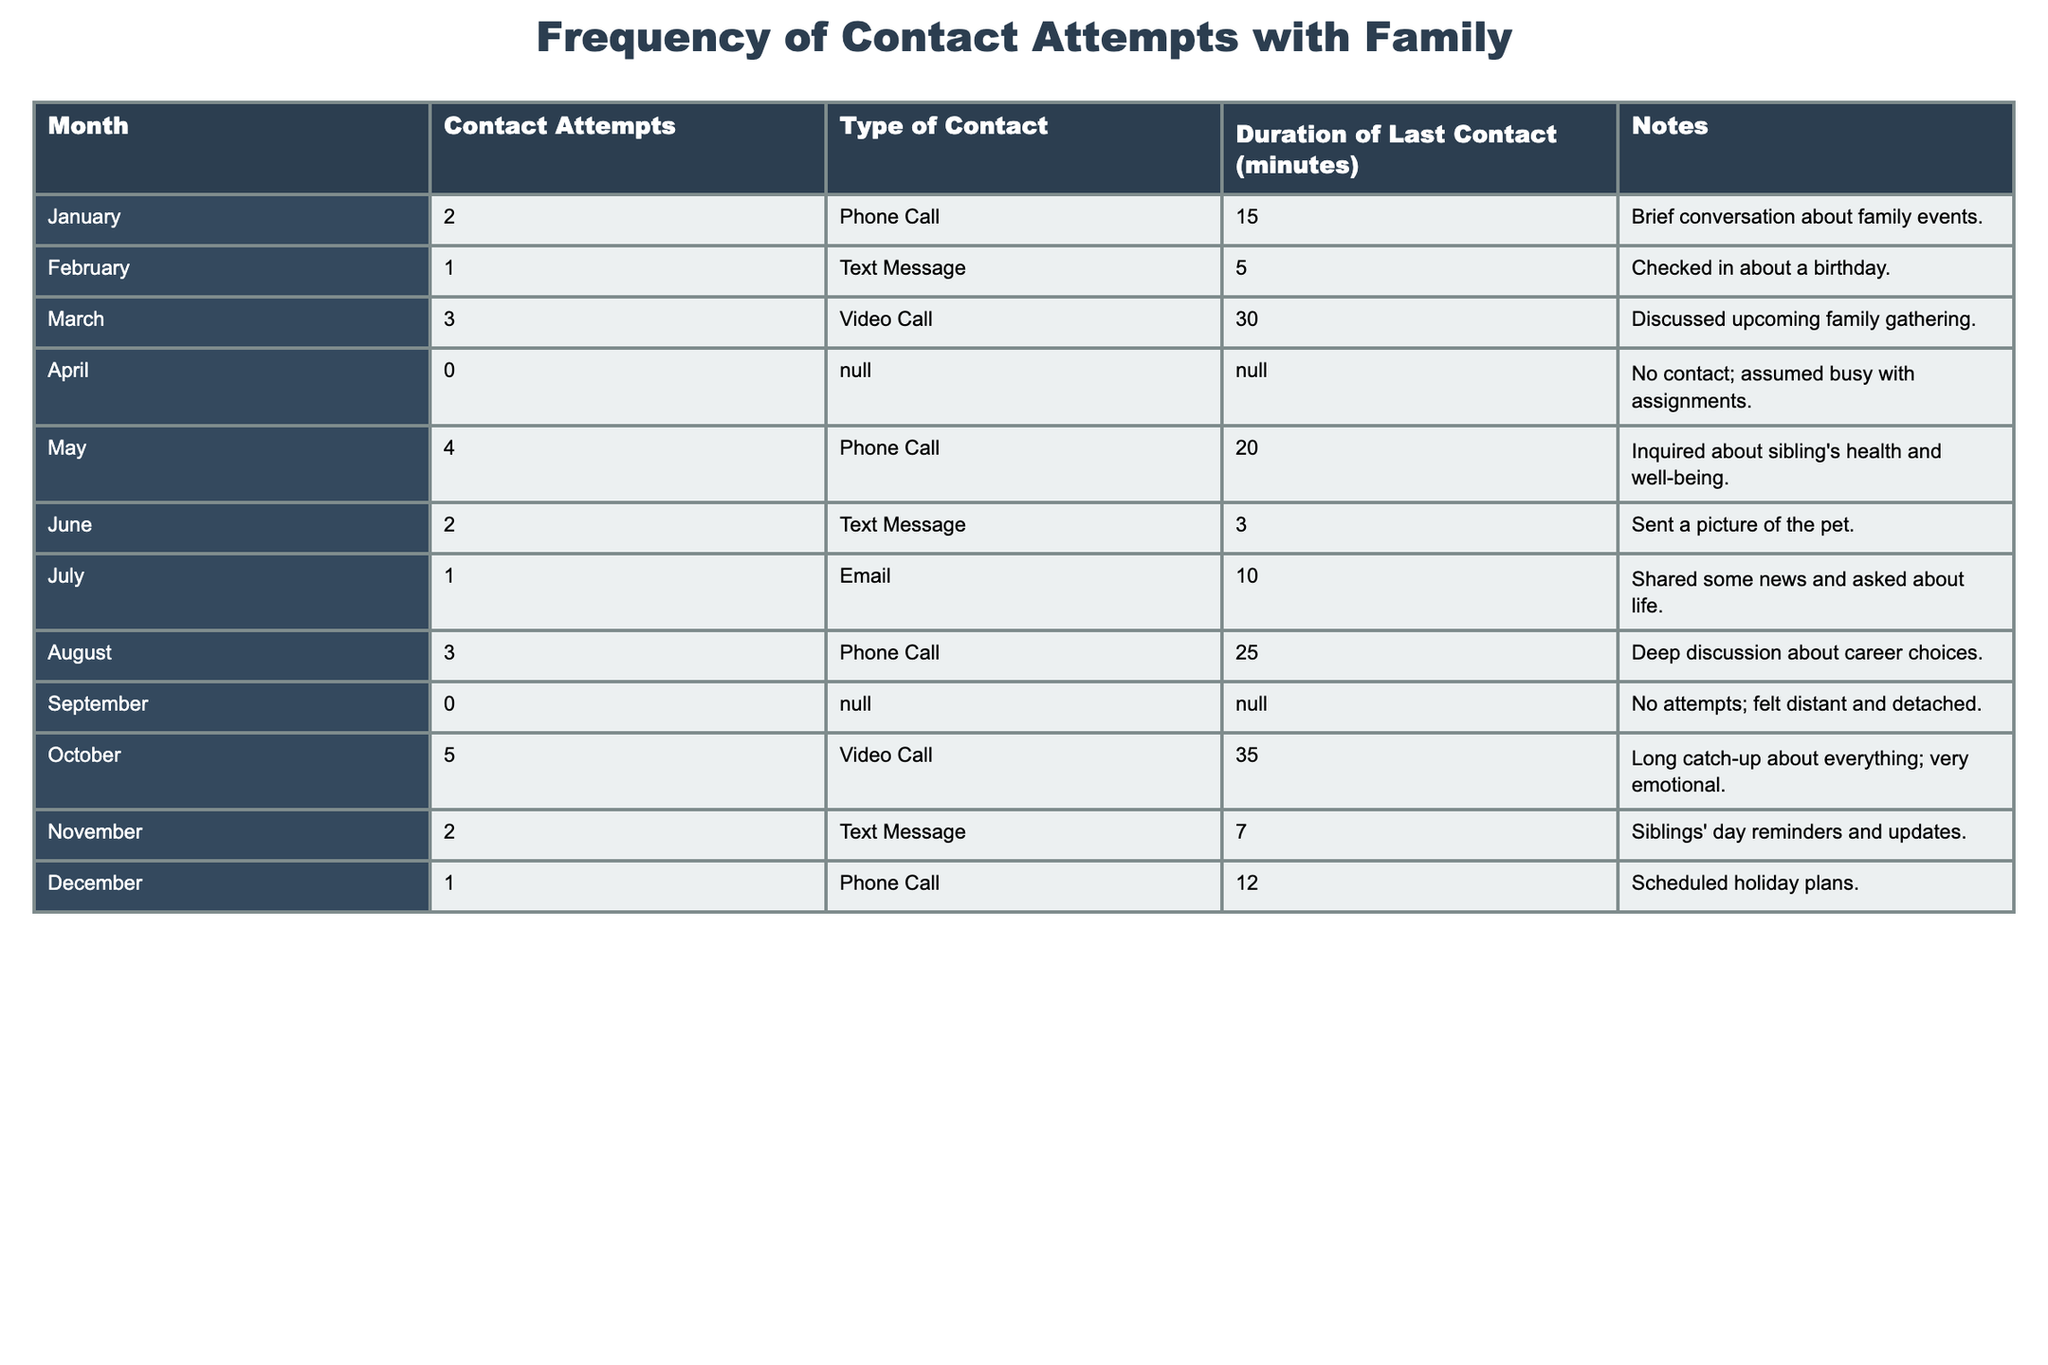What was the month with the highest number of contact attempts? By examining the "Contact Attempts" column, October has the highest value with 5 attempts.
Answer: October How many months had no contact attempts? The table shows that April and September had zero contact attempts, making it a total of 2 months.
Answer: 2 What is the total number of contact attempts made over the year? Summing the contact attempts across all months: 2 + 1 + 3 + 0 + 4 + 2 + 1 + 3 + 0 + 5 + 2 + 1 = 24.
Answer: 24 Which type of contact had the most attempts, and how many were there? By reviewing the "Type of Contact" and tallying, Phone Calls resulted in 10 attempts (2 in January, 4 in May, 3 in August, and 1 in December).
Answer: Phone Call, 10 Was there any month without phone calls? Yes, April and September had no contact attempts, meaning there were also no phone calls made in those months.
Answer: Yes What was the average duration of contact (in minutes) when contact attempts were made? Summing the durations for each month with contact attempts: (15 + 5 + 30 + 20 + 3 + 10 + 25 + 35 + 7 + 12) = 162 minutes; there were 10 months with contact, then the average is 162/10 = 16.2 minutes.
Answer: 16.2 minutes In which month did the longest contact occur and how long was it? October had the longest contact duration with a video call lasting 35 minutes.
Answer: October, 35 minutes How many contacts included emotional discussions? The table indicates emotional discussions in October (long catch-up), and deep discussions in August, totaling 2 months with emotional dialogues.
Answer: 2 months What kind of notes were taken in January and March? In January, the note was about a brief conversation discussing family events; in March, it noted a discussion about an upcoming family gathering.
Answer: Brief conversation about family events; discussion about family gathering 